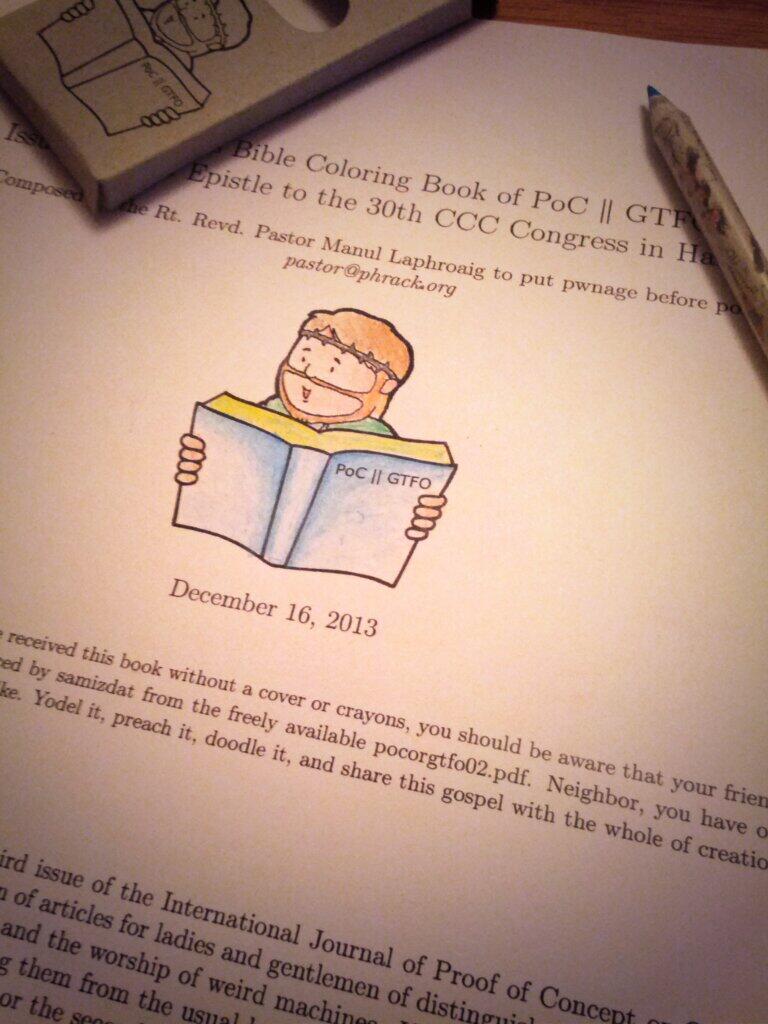What is the date under the image of the book?
Provide a short and direct response. December 16, 2013. What kind of coloring book?
Your answer should be very brief. Bible. 